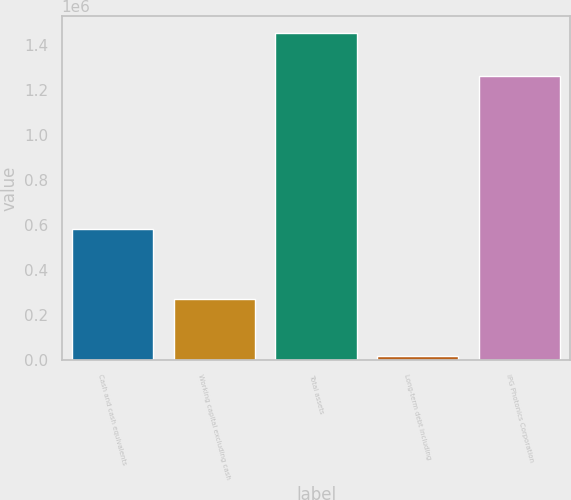Convert chart. <chart><loc_0><loc_0><loc_500><loc_500><bar_chart><fcel>Cash and cash equivalents<fcel>Working capital excluding cash<fcel>Total assets<fcel>Long-term debt including<fcel>IPG Photonics Corporation<nl><fcel>582532<fcel>271683<fcel>1.45343e+06<fcel>19667<fcel>1.25953e+06<nl></chart> 